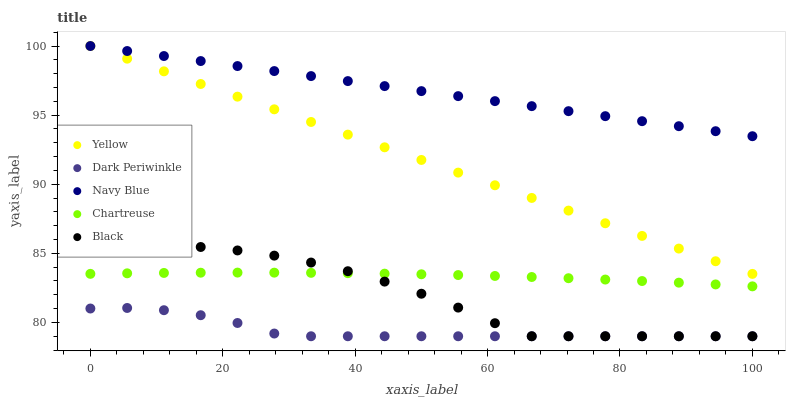Does Dark Periwinkle have the minimum area under the curve?
Answer yes or no. Yes. Does Navy Blue have the maximum area under the curve?
Answer yes or no. Yes. Does Chartreuse have the minimum area under the curve?
Answer yes or no. No. Does Chartreuse have the maximum area under the curve?
Answer yes or no. No. Is Navy Blue the smoothest?
Answer yes or no. Yes. Is Black the roughest?
Answer yes or no. Yes. Is Chartreuse the smoothest?
Answer yes or no. No. Is Chartreuse the roughest?
Answer yes or no. No. Does Black have the lowest value?
Answer yes or no. Yes. Does Chartreuse have the lowest value?
Answer yes or no. No. Does Yellow have the highest value?
Answer yes or no. Yes. Does Chartreuse have the highest value?
Answer yes or no. No. Is Black less than Yellow?
Answer yes or no. Yes. Is Yellow greater than Black?
Answer yes or no. Yes. Does Yellow intersect Navy Blue?
Answer yes or no. Yes. Is Yellow less than Navy Blue?
Answer yes or no. No. Is Yellow greater than Navy Blue?
Answer yes or no. No. Does Black intersect Yellow?
Answer yes or no. No. 